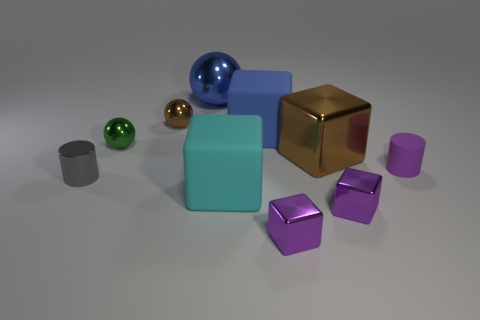There is a block that is the same color as the big metal ball; what size is it?
Your answer should be very brief. Large. The blue shiny thing that is the same shape as the tiny brown metallic thing is what size?
Ensure brevity in your answer.  Large. There is a ball that is the same color as the big metallic block; what is its material?
Give a very brief answer. Metal. What is the shape of the brown metallic thing to the right of the large metallic object that is behind the small brown sphere?
Provide a succinct answer. Cube. Is there another metal thing that has the same size as the gray object?
Keep it short and to the point. Yes. Is the number of small objects greater than the number of tiny brown metallic cylinders?
Your answer should be very brief. Yes. There is a matte cube behind the gray cylinder; is its size the same as the brown metallic sphere that is behind the small matte cylinder?
Provide a short and direct response. No. What number of tiny shiny objects are behind the large metallic block and on the right side of the big cyan rubber thing?
Your response must be concise. 0. There is a large metallic thing that is the same shape as the blue rubber object; what color is it?
Provide a succinct answer. Brown. Is the number of cylinders less than the number of large blocks?
Ensure brevity in your answer.  Yes. 